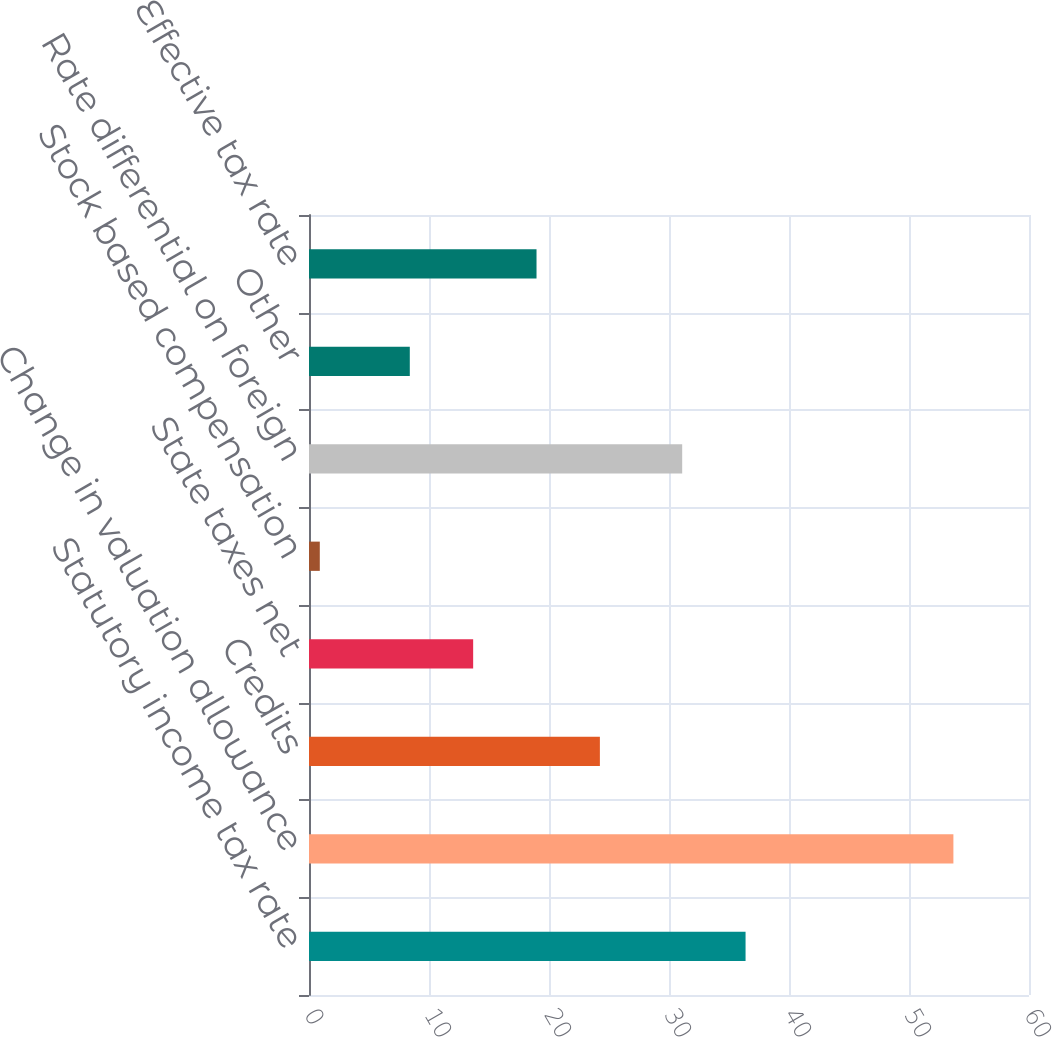<chart> <loc_0><loc_0><loc_500><loc_500><bar_chart><fcel>Statutory income tax rate<fcel>Change in valuation allowance<fcel>Credits<fcel>State taxes net<fcel>Stock based compensation<fcel>Rate differential on foreign<fcel>Other<fcel>Effective tax rate<nl><fcel>36.38<fcel>53.7<fcel>24.24<fcel>13.68<fcel>0.9<fcel>31.1<fcel>8.4<fcel>18.96<nl></chart> 